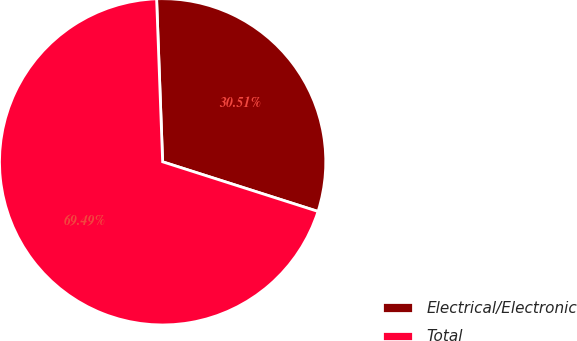Convert chart. <chart><loc_0><loc_0><loc_500><loc_500><pie_chart><fcel>Electrical/Electronic<fcel>Total<nl><fcel>30.51%<fcel>69.49%<nl></chart> 